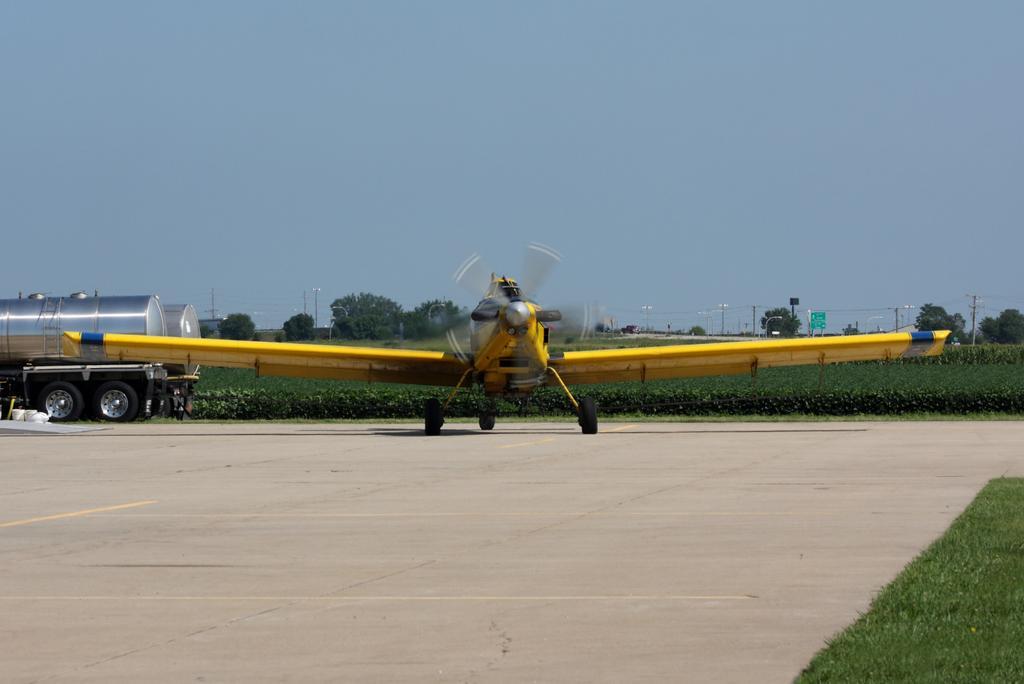Could you give a brief overview of what you see in this image? In this image we can see a airplane with propeller attached to it is placed on the road. In the background we can see vehicles parked on the ground ,group of trees ,poles and sky. 